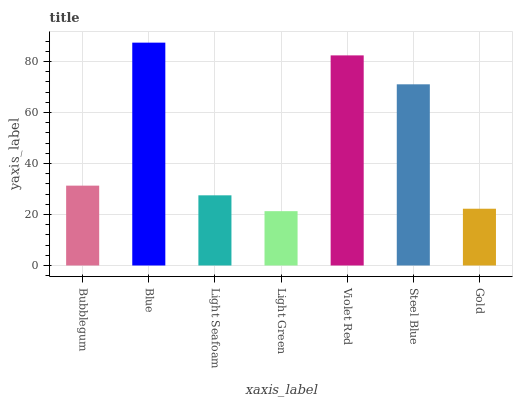Is Light Green the minimum?
Answer yes or no. Yes. Is Blue the maximum?
Answer yes or no. Yes. Is Light Seafoam the minimum?
Answer yes or no. No. Is Light Seafoam the maximum?
Answer yes or no. No. Is Blue greater than Light Seafoam?
Answer yes or no. Yes. Is Light Seafoam less than Blue?
Answer yes or no. Yes. Is Light Seafoam greater than Blue?
Answer yes or no. No. Is Blue less than Light Seafoam?
Answer yes or no. No. Is Bubblegum the high median?
Answer yes or no. Yes. Is Bubblegum the low median?
Answer yes or no. Yes. Is Blue the high median?
Answer yes or no. No. Is Light Green the low median?
Answer yes or no. No. 